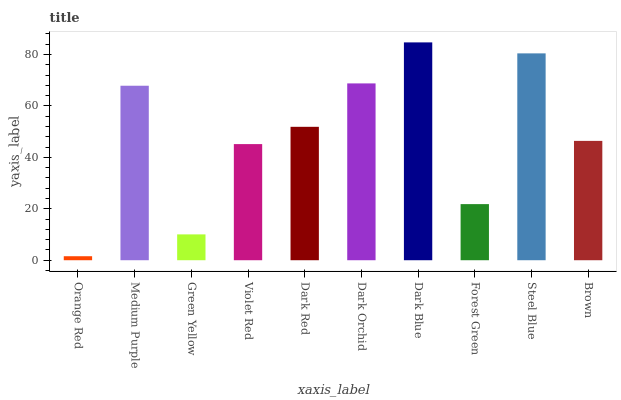Is Orange Red the minimum?
Answer yes or no. Yes. Is Dark Blue the maximum?
Answer yes or no. Yes. Is Medium Purple the minimum?
Answer yes or no. No. Is Medium Purple the maximum?
Answer yes or no. No. Is Medium Purple greater than Orange Red?
Answer yes or no. Yes. Is Orange Red less than Medium Purple?
Answer yes or no. Yes. Is Orange Red greater than Medium Purple?
Answer yes or no. No. Is Medium Purple less than Orange Red?
Answer yes or no. No. Is Dark Red the high median?
Answer yes or no. Yes. Is Brown the low median?
Answer yes or no. Yes. Is Violet Red the high median?
Answer yes or no. No. Is Dark Orchid the low median?
Answer yes or no. No. 